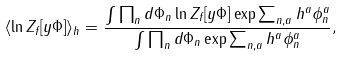<formula> <loc_0><loc_0><loc_500><loc_500>\langle \ln Z _ { f } [ y \Phi ] \rangle _ { h } = \frac { \int \prod _ { n } d \Phi _ { n } \ln Z _ { f } [ y \Phi ] \exp \sum _ { n , a } h ^ { a } \phi ^ { a } _ { n } } { \int \prod _ { n } d \Phi _ { n } \exp \sum _ { n , a } h ^ { a } \phi ^ { a } _ { n } } ,</formula> 